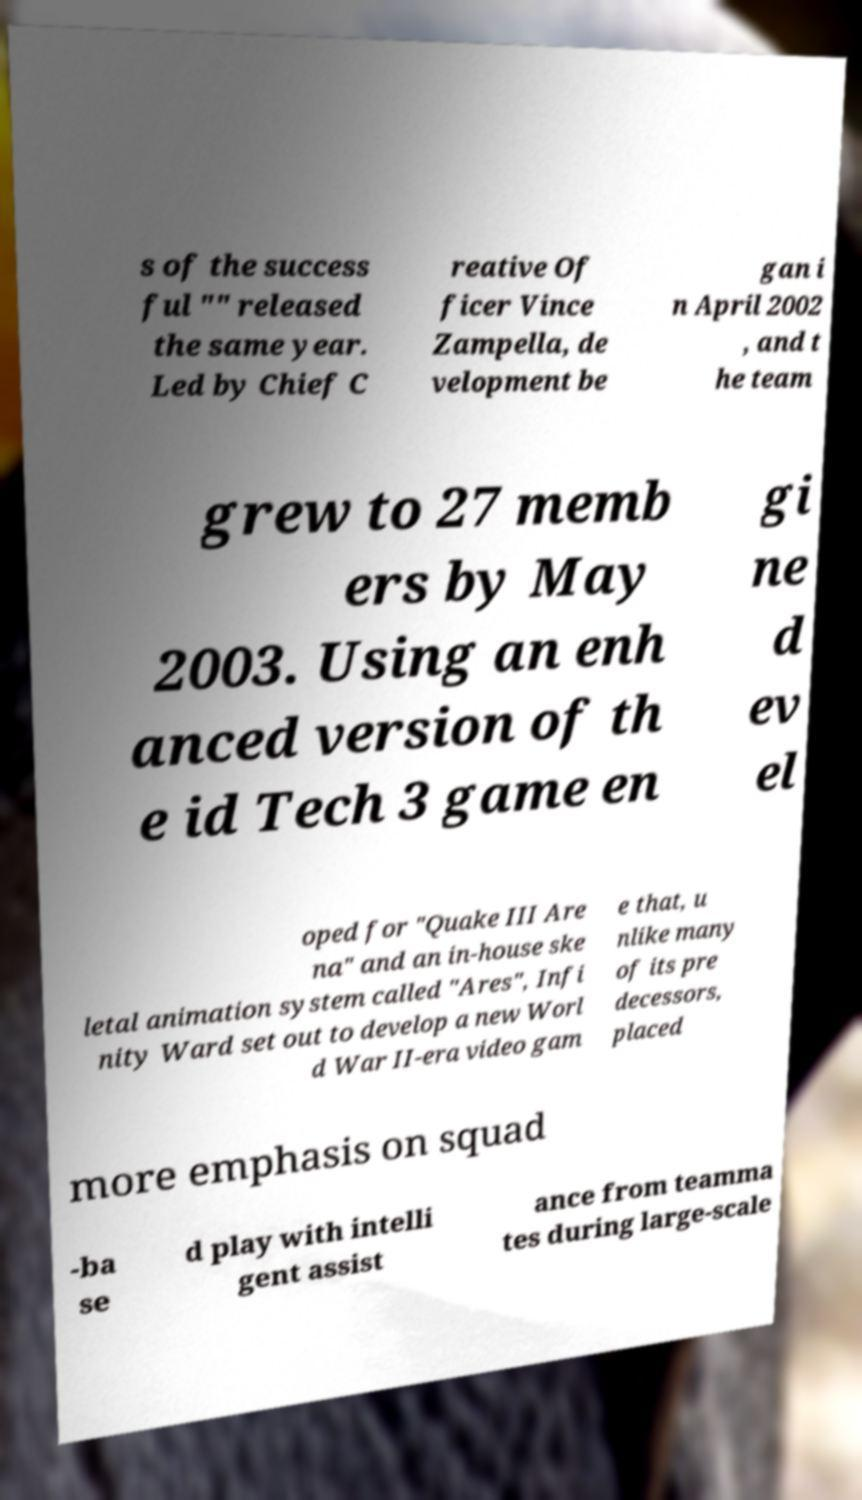I need the written content from this picture converted into text. Can you do that? s of the success ful "" released the same year. Led by Chief C reative Of ficer Vince Zampella, de velopment be gan i n April 2002 , and t he team grew to 27 memb ers by May 2003. Using an enh anced version of th e id Tech 3 game en gi ne d ev el oped for "Quake III Are na" and an in-house ske letal animation system called "Ares", Infi nity Ward set out to develop a new Worl d War II-era video gam e that, u nlike many of its pre decessors, placed more emphasis on squad -ba se d play with intelli gent assist ance from teamma tes during large-scale 